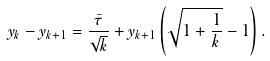Convert formula to latex. <formula><loc_0><loc_0><loc_500><loc_500>y _ { k } - y _ { k + 1 } = \frac { \bar { \tau } } { \sqrt { k } } + y _ { k + 1 } \left ( \sqrt { 1 + \frac { 1 } { k } } - 1 \right ) .</formula> 